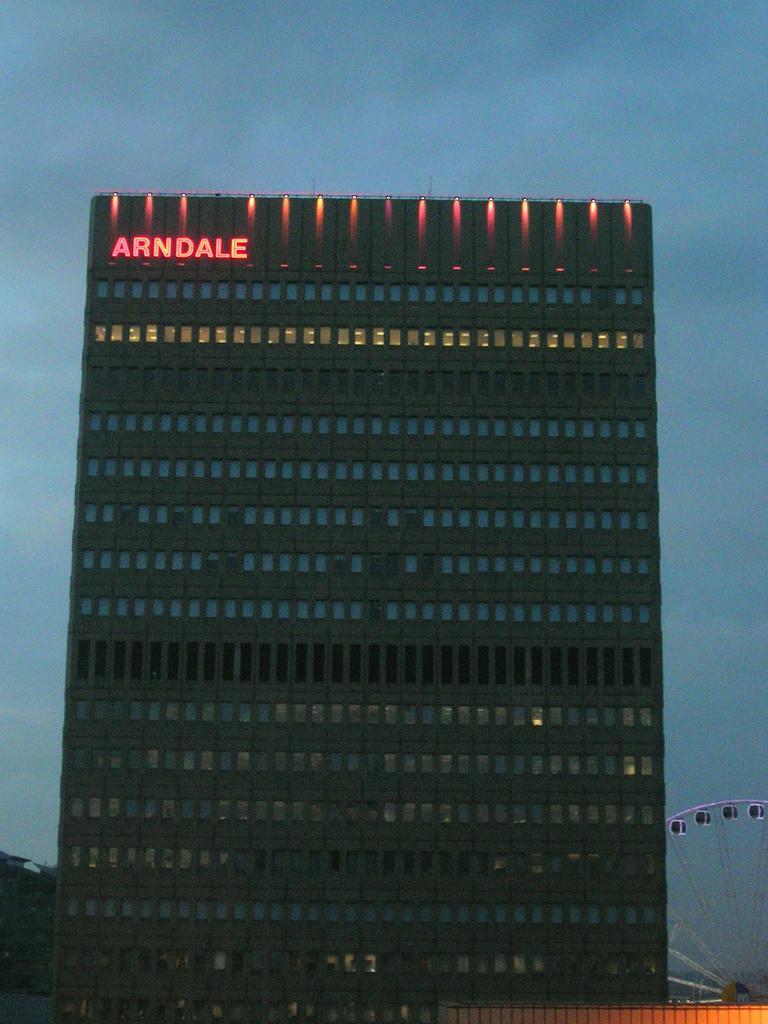Can you describe this image briefly? In this picture there is a building. On the top left corner of the building we can see name board and lights. On the bottom right corner there is a wheel. On the top we can see sky and clouds. 